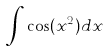Convert formula to latex. <formula><loc_0><loc_0><loc_500><loc_500>\int \cos ( x ^ { 2 } ) d x</formula> 